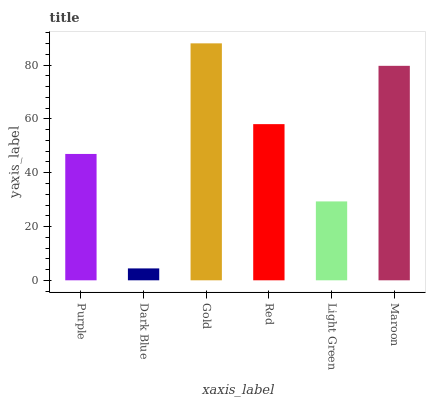Is Dark Blue the minimum?
Answer yes or no. Yes. Is Gold the maximum?
Answer yes or no. Yes. Is Gold the minimum?
Answer yes or no. No. Is Dark Blue the maximum?
Answer yes or no. No. Is Gold greater than Dark Blue?
Answer yes or no. Yes. Is Dark Blue less than Gold?
Answer yes or no. Yes. Is Dark Blue greater than Gold?
Answer yes or no. No. Is Gold less than Dark Blue?
Answer yes or no. No. Is Red the high median?
Answer yes or no. Yes. Is Purple the low median?
Answer yes or no. Yes. Is Purple the high median?
Answer yes or no. No. Is Red the low median?
Answer yes or no. No. 